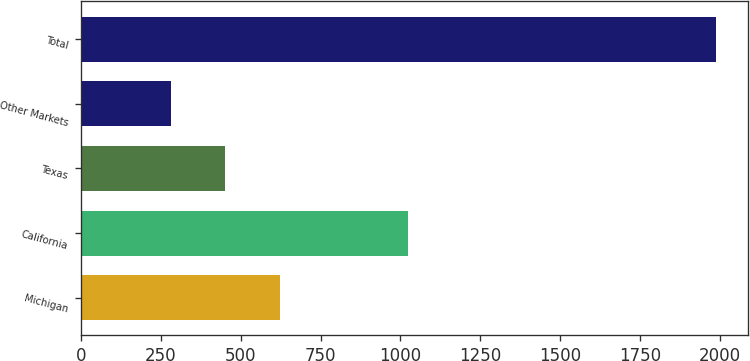<chart> <loc_0><loc_0><loc_500><loc_500><bar_chart><fcel>Michigan<fcel>California<fcel>Texas<fcel>Other Markets<fcel>Total<nl><fcel>622.4<fcel>1023<fcel>451.7<fcel>281<fcel>1988<nl></chart> 